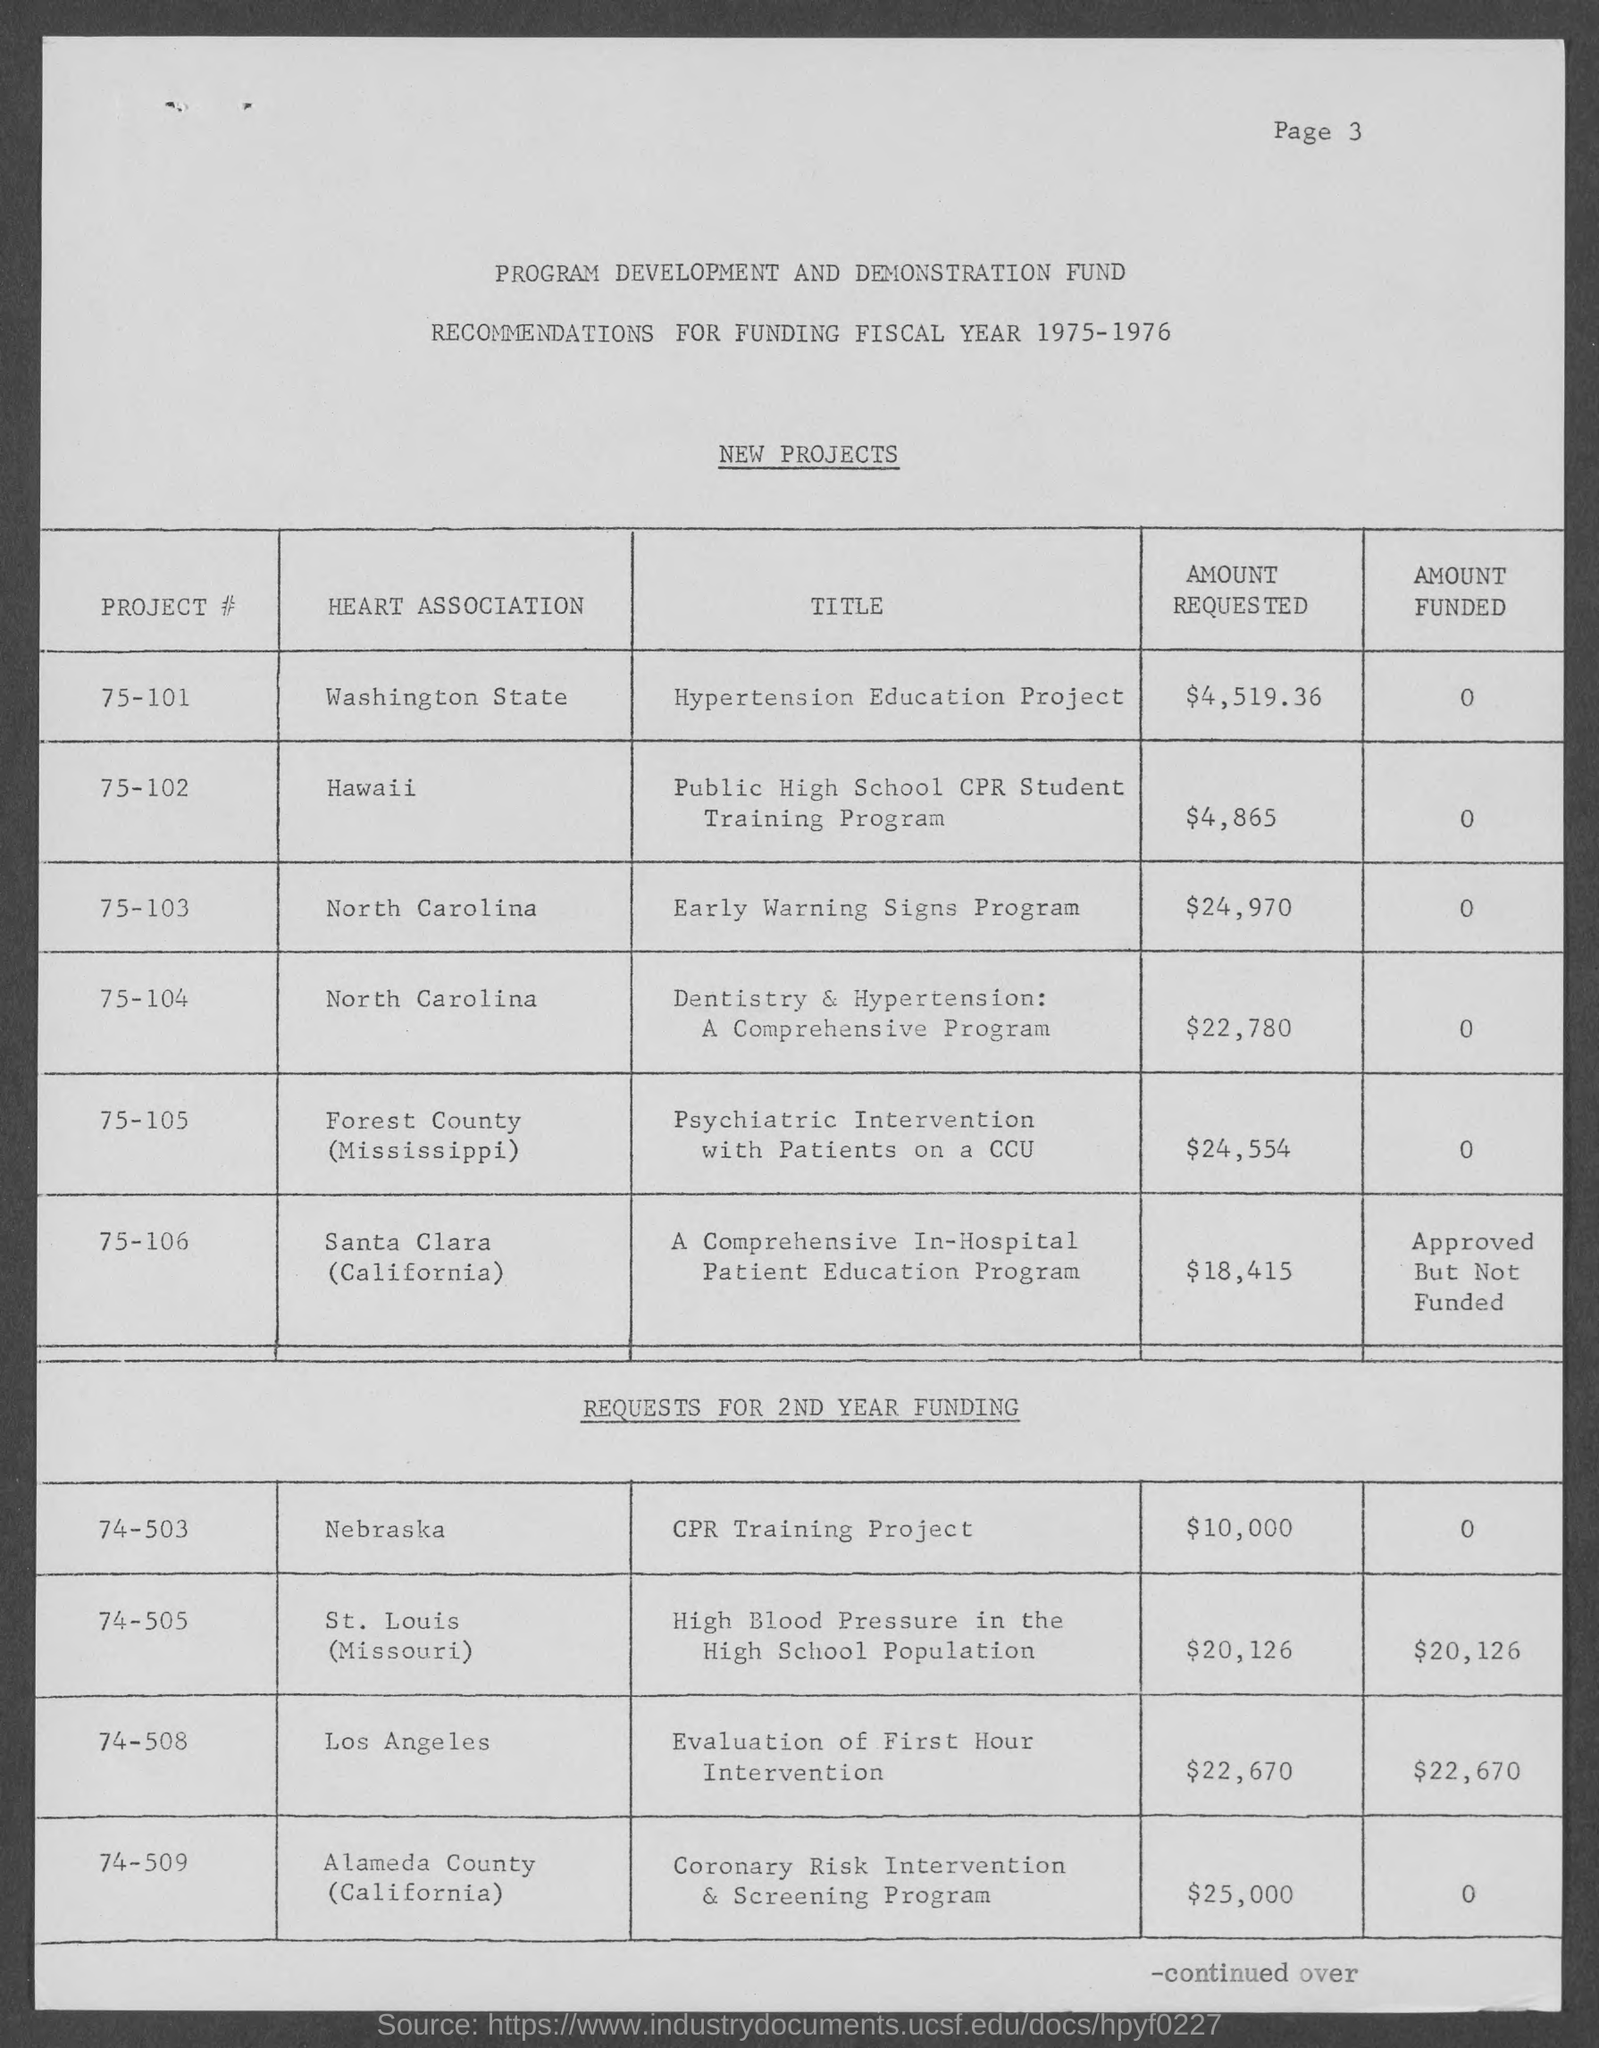List a handful of essential elements in this visual. The recommendations are for the fiscal year of 1975-1976. The Early Warning Signs Program has a requested amount of $24,970. The amount requested for the Public High School CPR Student Training Program is $4,865. The page number at the top of the page is 3. The total amount requested for the Dentistry & Hypertension: A Comprehensive Program is $22,780. 